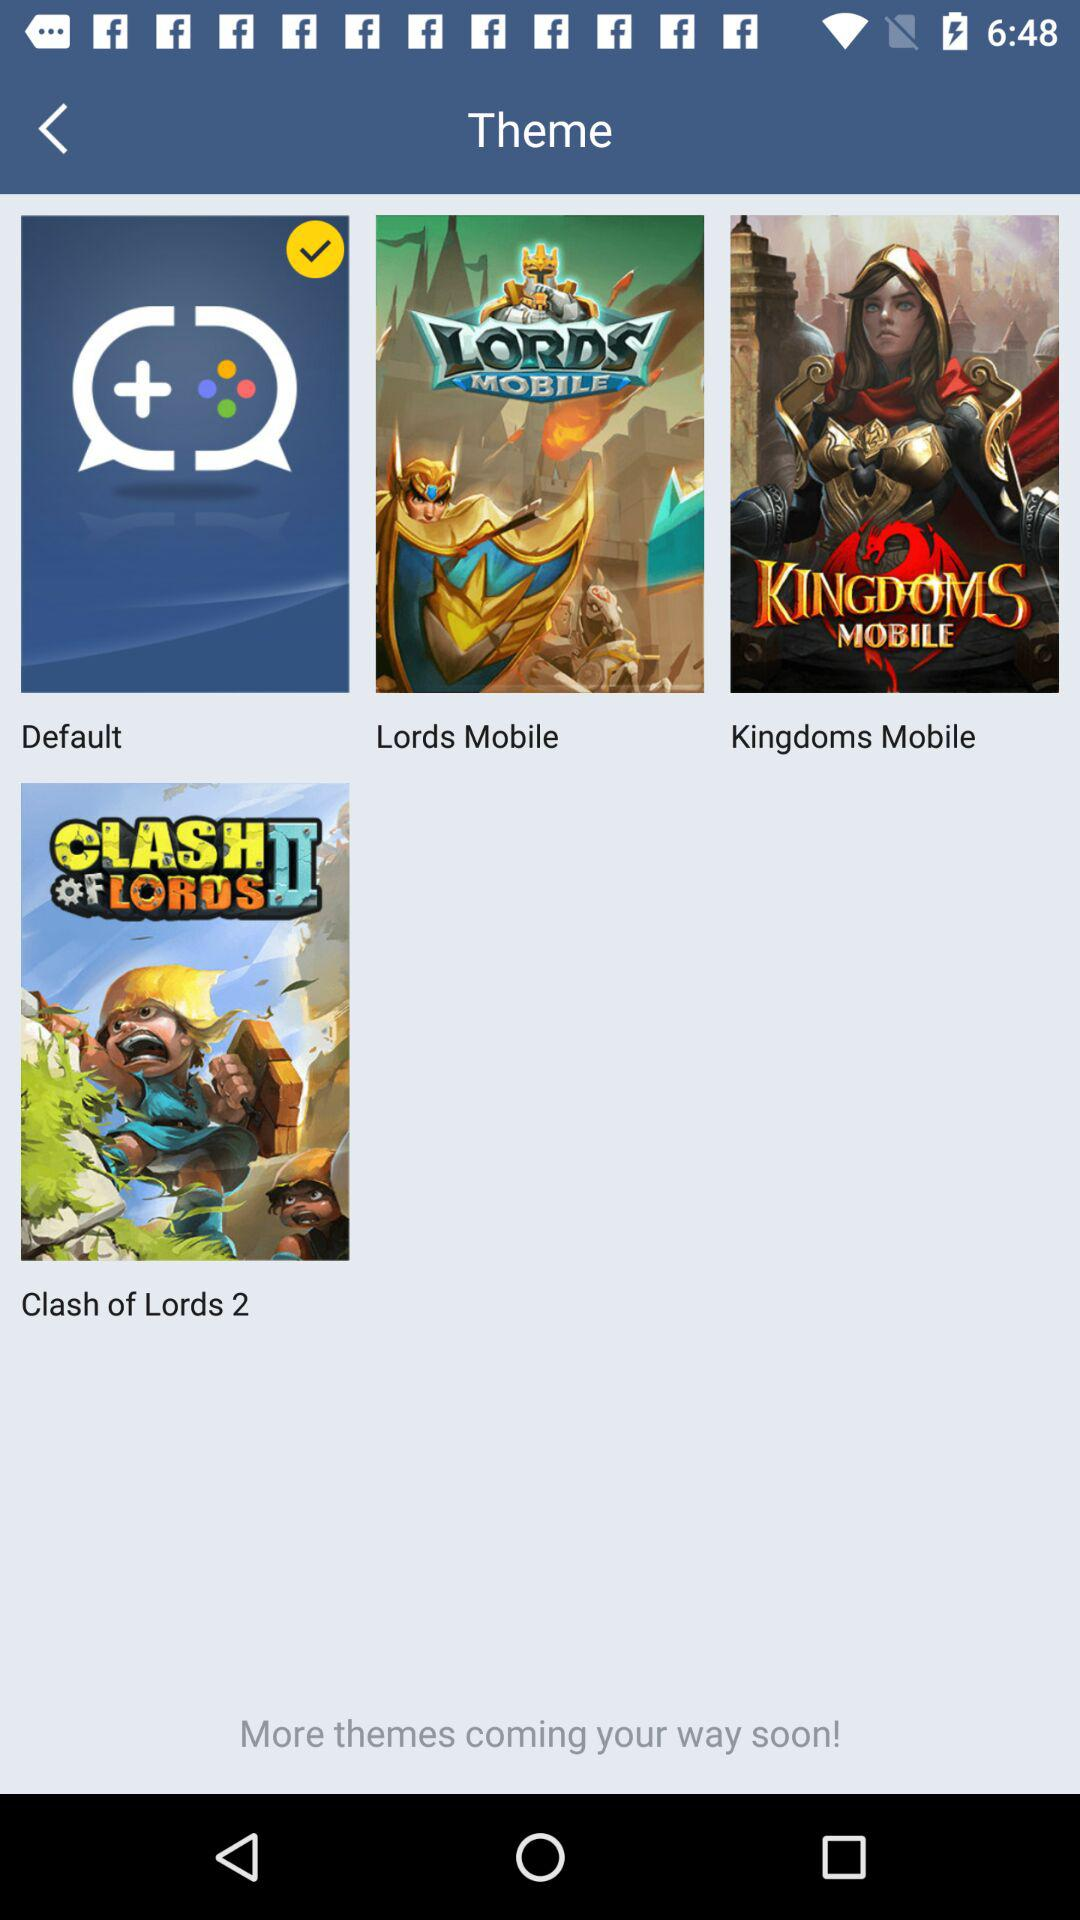How many themes are there in total?
Answer the question using a single word or phrase. 4 